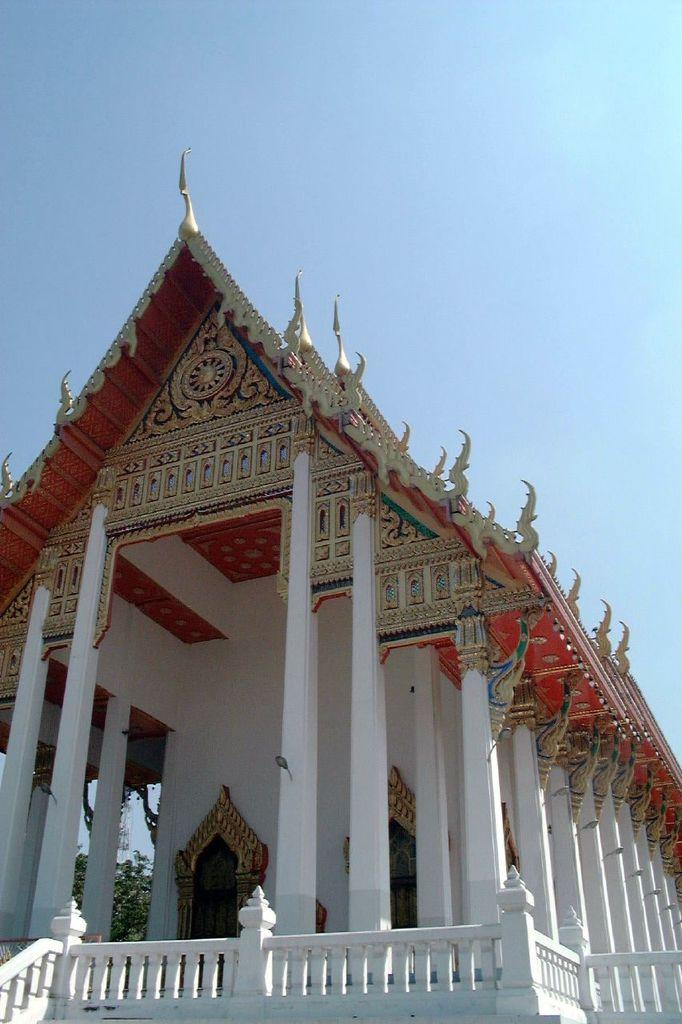What type of structure is featured in the image? There is a colorful building in the image. What architectural feature can be seen on the building? The building has white pillars. What can be seen in the background of the image? The sky is visible in the background of the image. What is the color of the sky in the image? The sky is blue in color. What is the expert's opinion on the rate of the blade in the image? There is no expert, rate, or blade present in the image. 